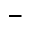Convert formula to latex. <formula><loc_0><loc_0><loc_500><loc_500>\_</formula> 